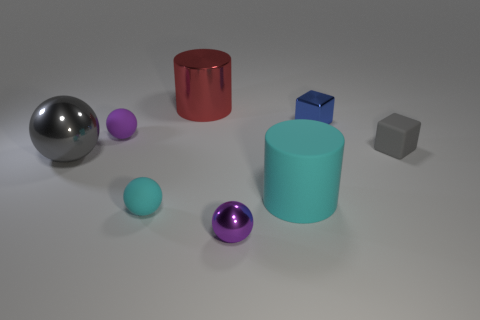Subtract all gray spheres. How many spheres are left? 3 Add 1 tiny purple matte things. How many objects exist? 9 Subtract all green blocks. How many purple spheres are left? 2 Subtract all gray balls. How many balls are left? 3 Subtract all cylinders. How many objects are left? 6 Subtract 2 cylinders. How many cylinders are left? 0 Subtract all cyan cylinders. Subtract all blue cubes. How many cylinders are left? 1 Subtract all large brown shiny spheres. Subtract all tiny matte spheres. How many objects are left? 6 Add 6 large objects. How many large objects are left? 9 Add 1 tiny cyan matte objects. How many tiny cyan matte objects exist? 2 